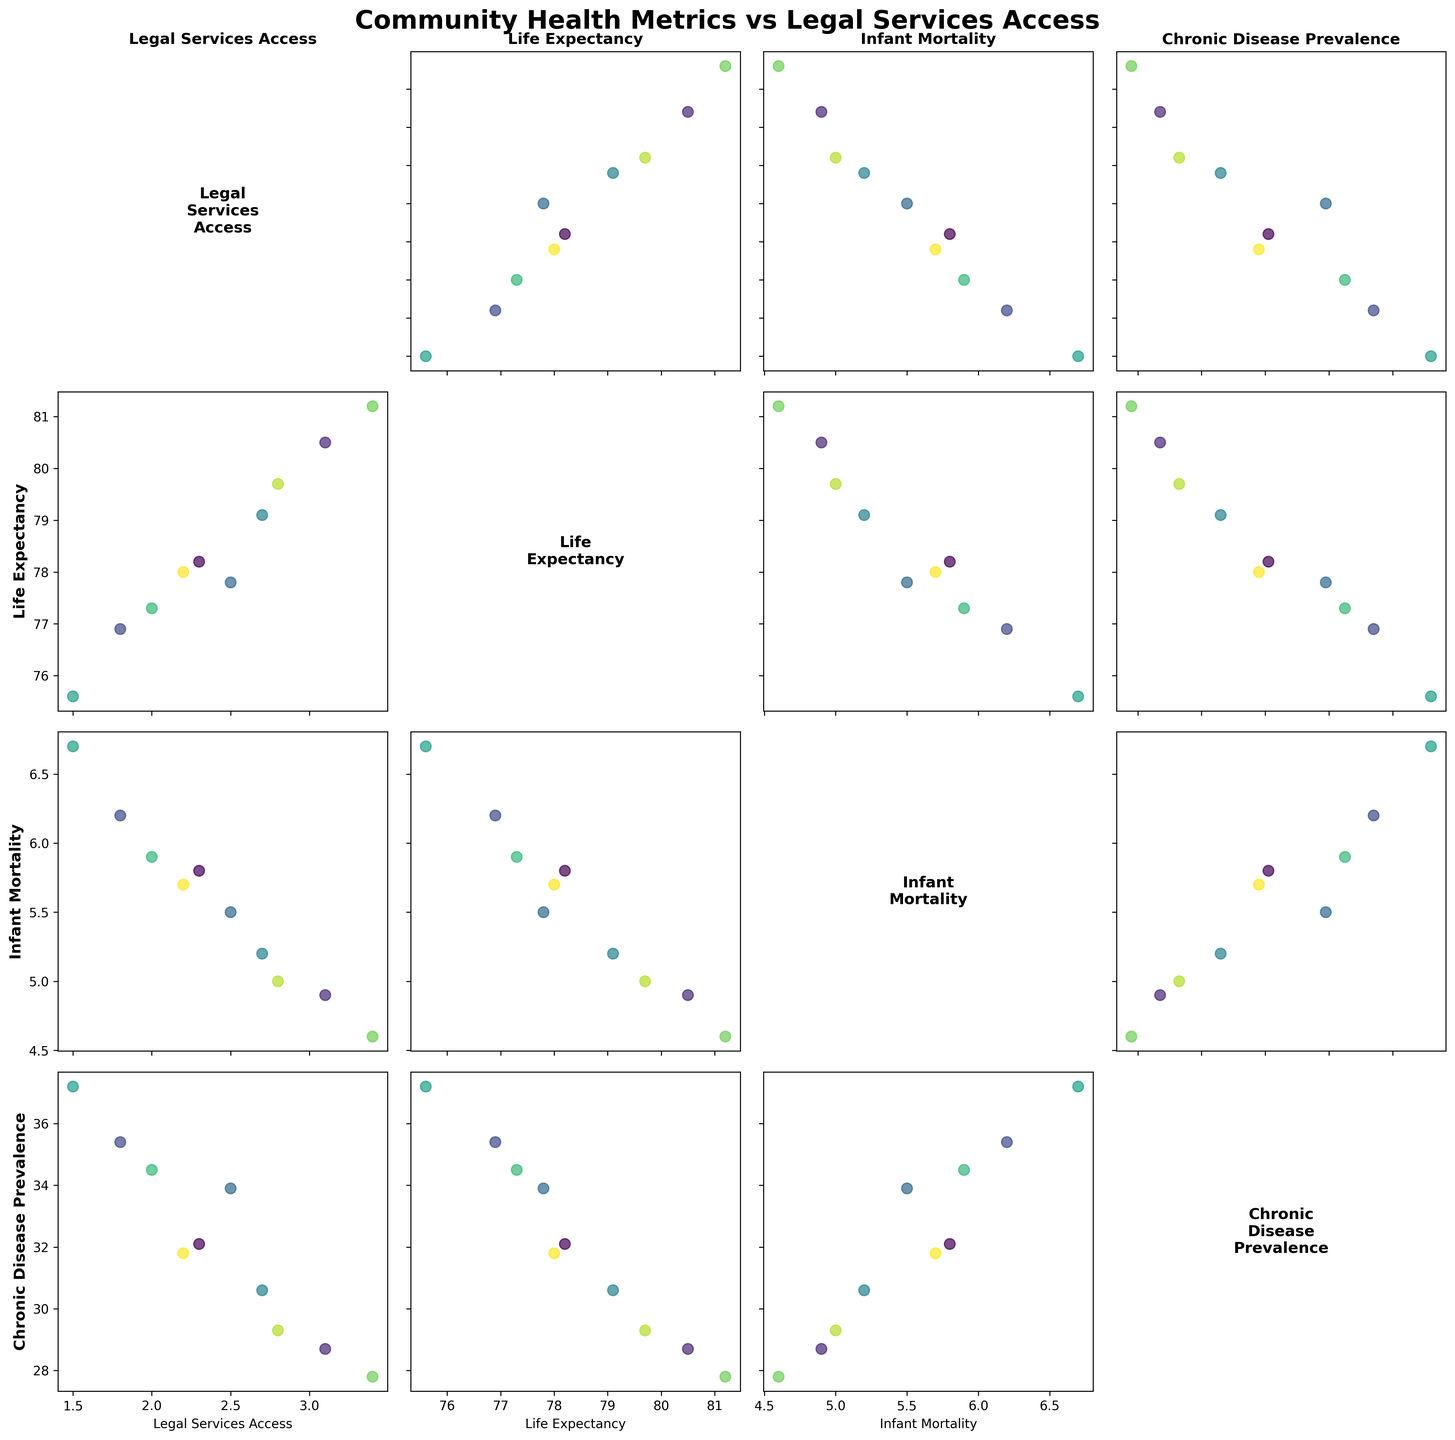What is represented on the x- and y-axes of the scatterplots? The x- and y-axes represent different variables from the dataset. They include 'Legal Services Access', 'Life Expectancy', 'Infant Mortality', and 'Chronic Disease Prevalence'. Each scatterplot has a unique combination of these variables on its axes.
Answer: Different health metrics and access to legal services Which variable seems to have the strongest correlation with 'Legal Services Access'? To find the strongest correlation, look for the tightest clustering of points along a trend line in scatterplots involving 'Legal Services Access' on one axis. The variables to compare would be 'Life Expectancy', 'Infant Mortality', and 'Chronic Disease Prevalence'.
Answer: Life Expectancy How does 'Infant Mortality' vary with 'Legal Services Access'? Examine the scatterplot where 'Infant Mortality' is plotted against 'Legal Services Access'. Look for patterns such as a downward or upward trend of points.
Answer: Higher access tends to associate with lower infant mortality Which community has the highest level of 'Chronic Disease Prevalence'? Find the scatterplot that includes 'Chronic Disease Prevalence' and look at the positioning of the points. Identify the community corresponding to the highest value on the appropriate axis.
Answer: Detroit Eastside Is there any visible trend between 'Life Expectancy' and 'Chronic Disease Prevalence'? Look at the scatterplot with 'Life Expectancy' on one axis and 'Chronic Disease Prevalence' on the other and examine if the points form any recognizable trend.
Answer: Generally, higher chronic disease prevalence correlates with lower life expectancy What is the title of the scatterplot matrix? The title is located at the top of the plot and often provides insight into the main focus of the figure.
Answer: Community Health Metrics vs Legal Services Access How many data points are plotted in each scatterplot? Count the points in any single scatterplot within the matrix. Since each scatterplot includes data from the same communities, the count should be consistent across plots.
Answer: 10 Which two communities have the most similar 'Legal Services Access' values? Compare the x- or y-values of the community points in the scatterplots involving 'Legal Services Access'. Find the pairs with the smallest difference.
Answer: South Bronx and Cleveland East Side What is the general trend between 'Legal Services Access' and 'Life Expectancy'? Look at the scatterplot with 'Legal Services Access' on one axis and 'Life Expectancy' on the other. Observe if the points follow an upward or downward trend.
Answer: Positive trend (higher access, higher life expectancy) Which community falls at the lower end of 'Life Expectancy' in the scatterplots? Examine the scatterplots involving 'Life Expectancy' and identify the point at the lowest end of the 'Life Expectancy' axis. Determine which community corresponds to that point.
Answer: Detroit Eastside 